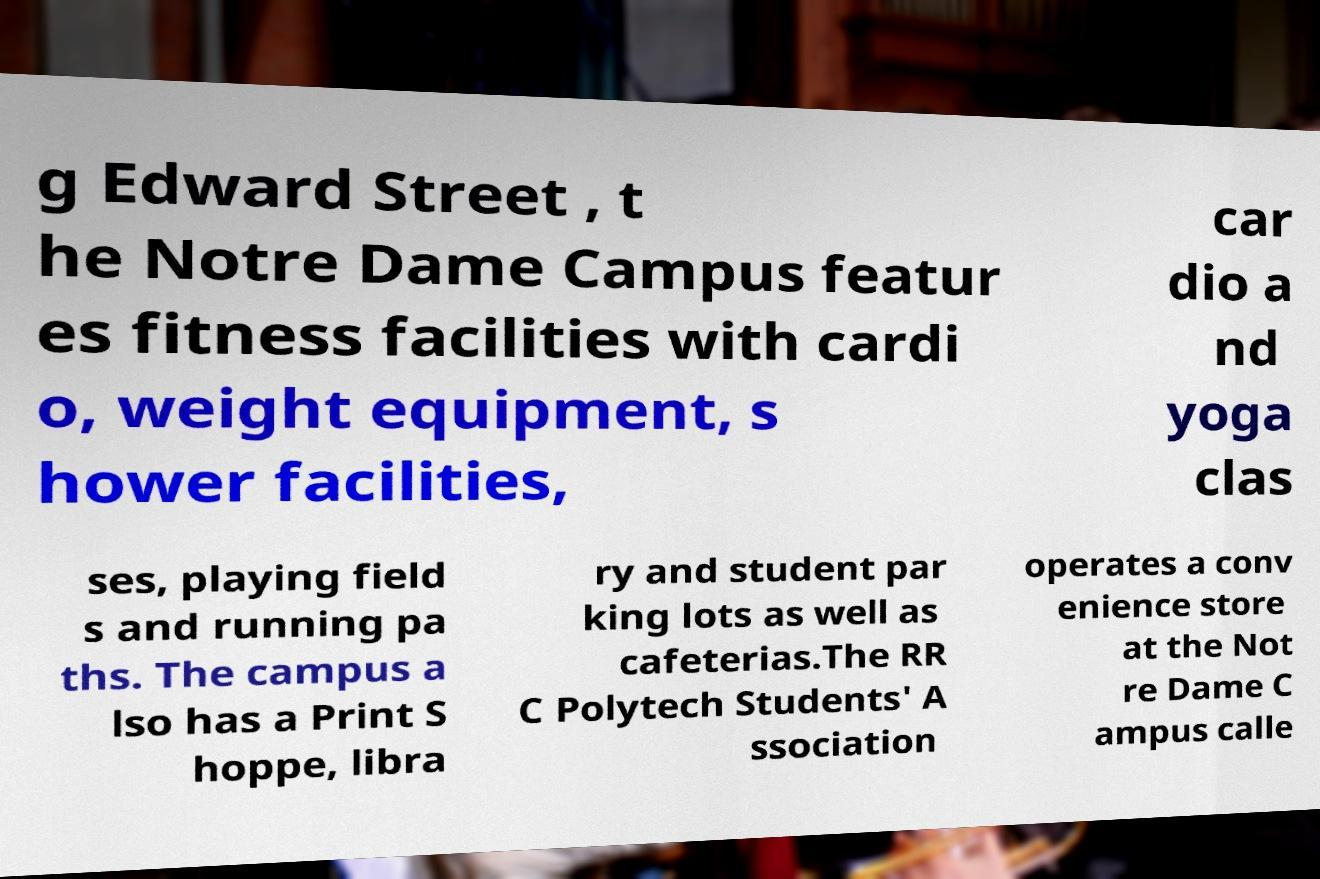Could you extract and type out the text from this image? g Edward Street , t he Notre Dame Campus featur es fitness facilities with cardi o, weight equipment, s hower facilities, car dio a nd yoga clas ses, playing field s and running pa ths. The campus a lso has a Print S hoppe, libra ry and student par king lots as well as cafeterias.The RR C Polytech Students' A ssociation operates a conv enience store at the Not re Dame C ampus calle 